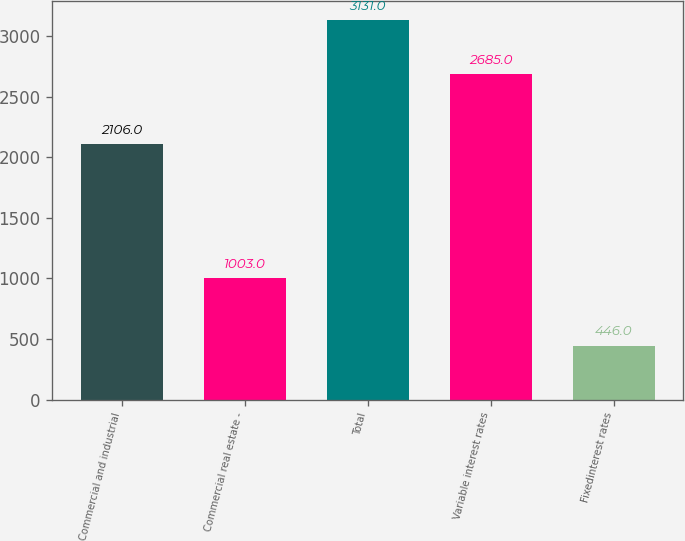Convert chart. <chart><loc_0><loc_0><loc_500><loc_500><bar_chart><fcel>Commercial and industrial<fcel>Commercial real estate -<fcel>Total<fcel>Variable interest rates<fcel>Fixedinterest rates<nl><fcel>2106<fcel>1003<fcel>3131<fcel>2685<fcel>446<nl></chart> 